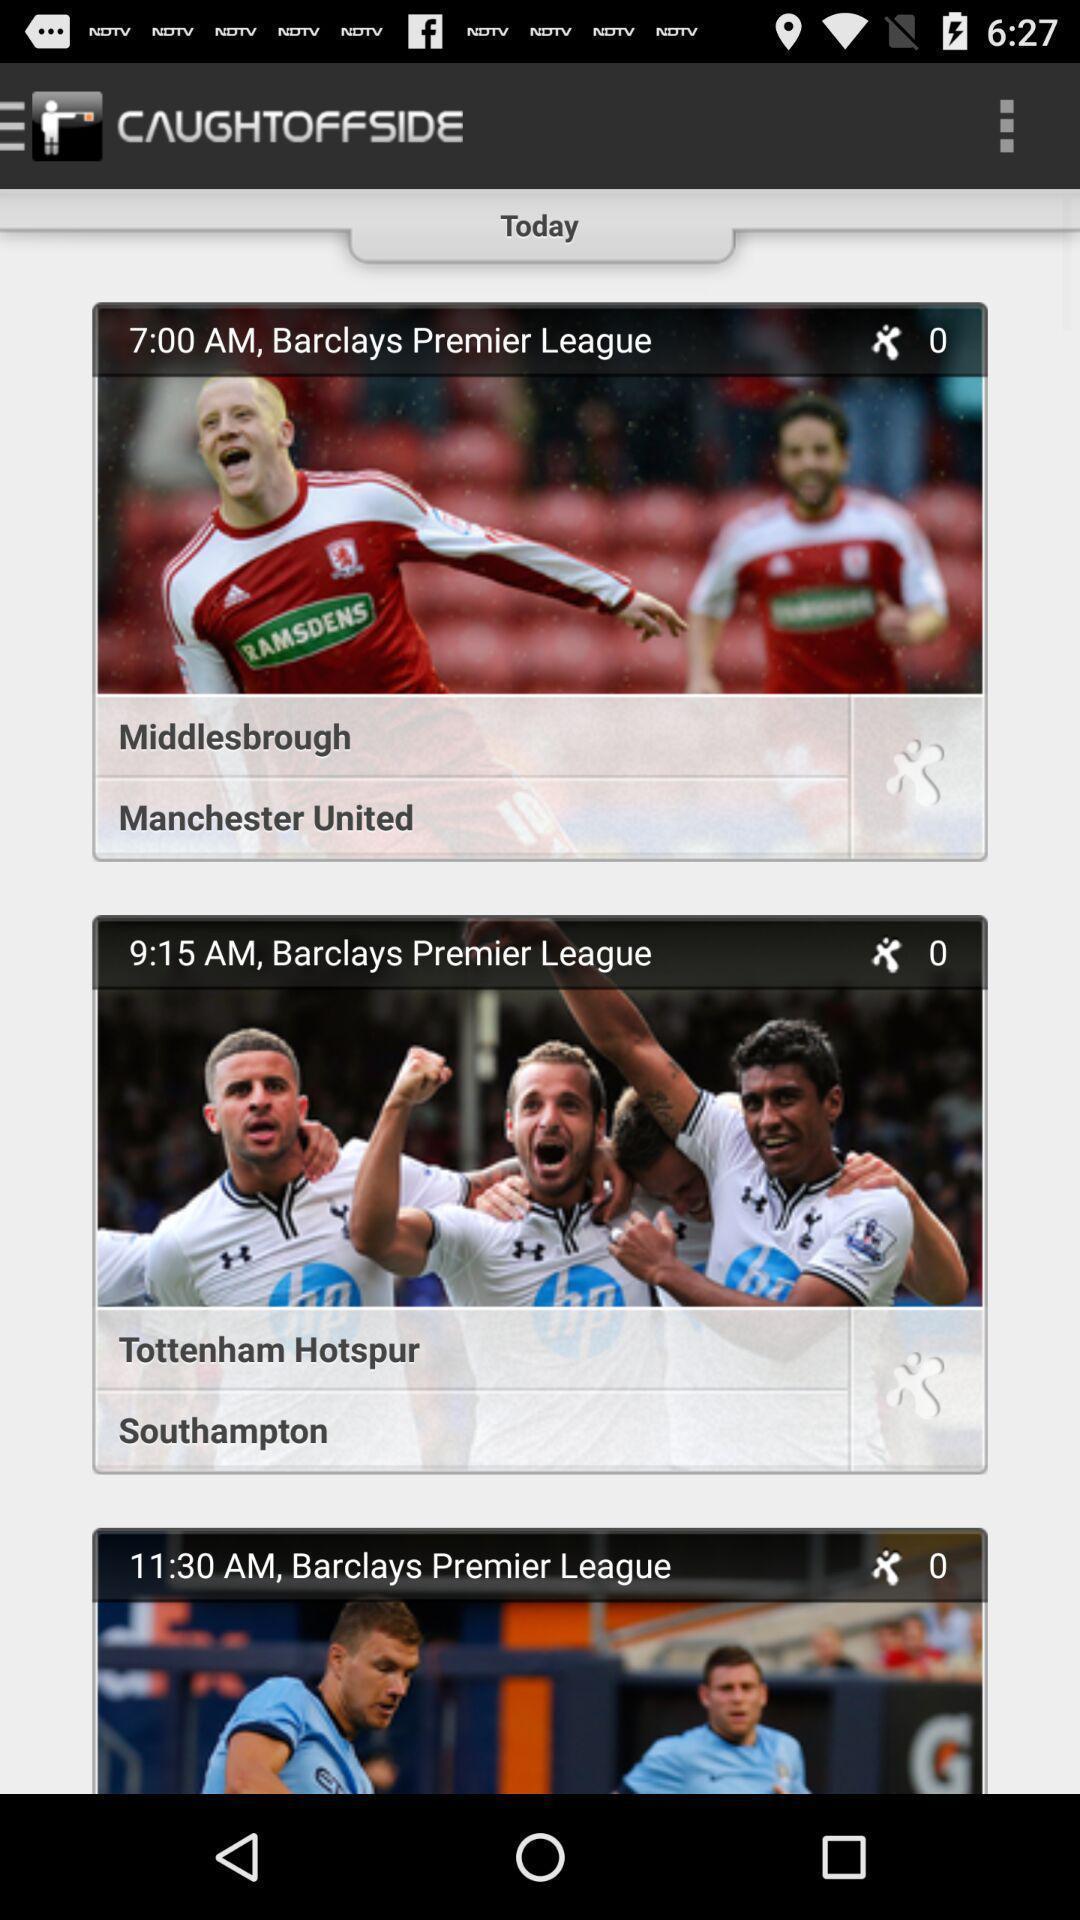Give me a narrative description of this picture. Page showing videos in sports app. 